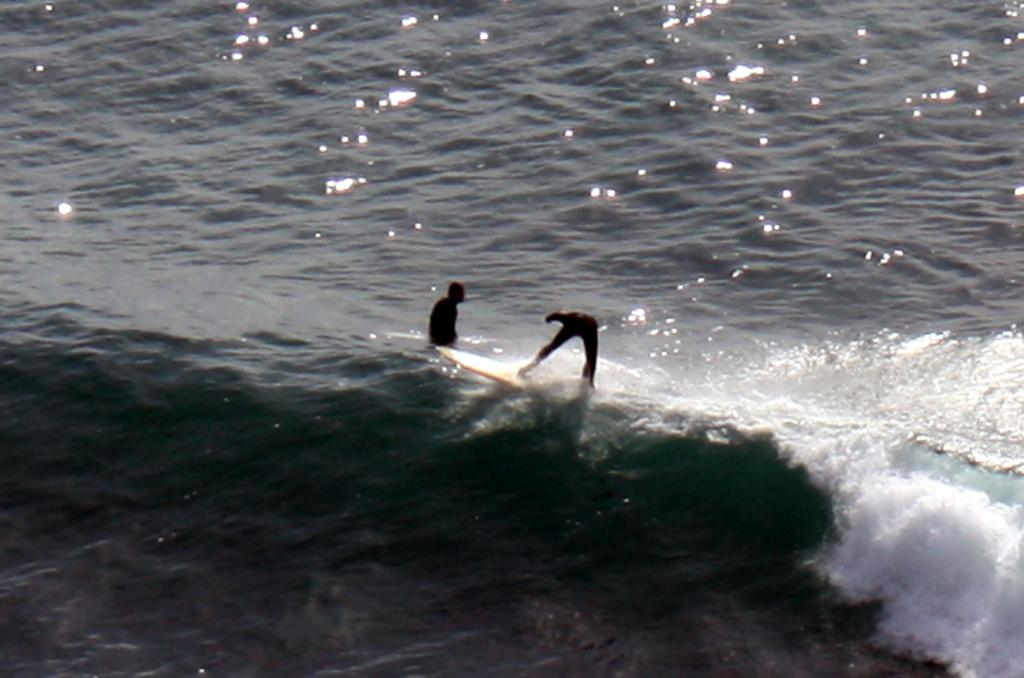What is the main element present in the image? There is water in the image. Are there any people in the water? Yes, two persons are present in the water. What are the persons doing in the water? The persons are surfing. What equipment are the persons using for surfing? The persons are using surfboards. What type of milk can be seen in the image? There is no milk present in the image; it features water and people surfing. Are the persons in the image ringing any bells? There are no bells present in the image. 